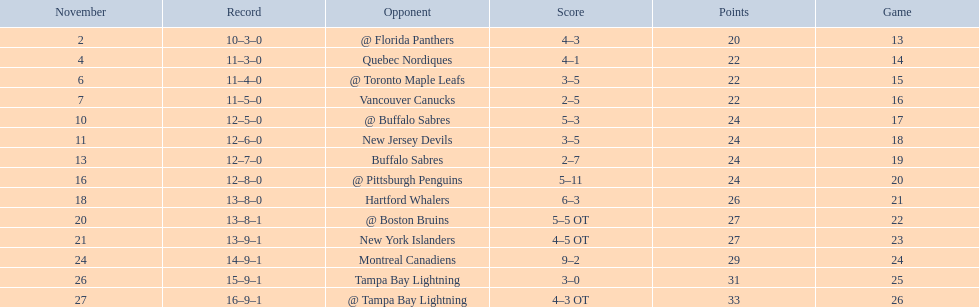The 1993-1994 flyers missed the playoffs again. how many consecutive seasons up until 93-94 did the flyers miss the playoffs? 5. 